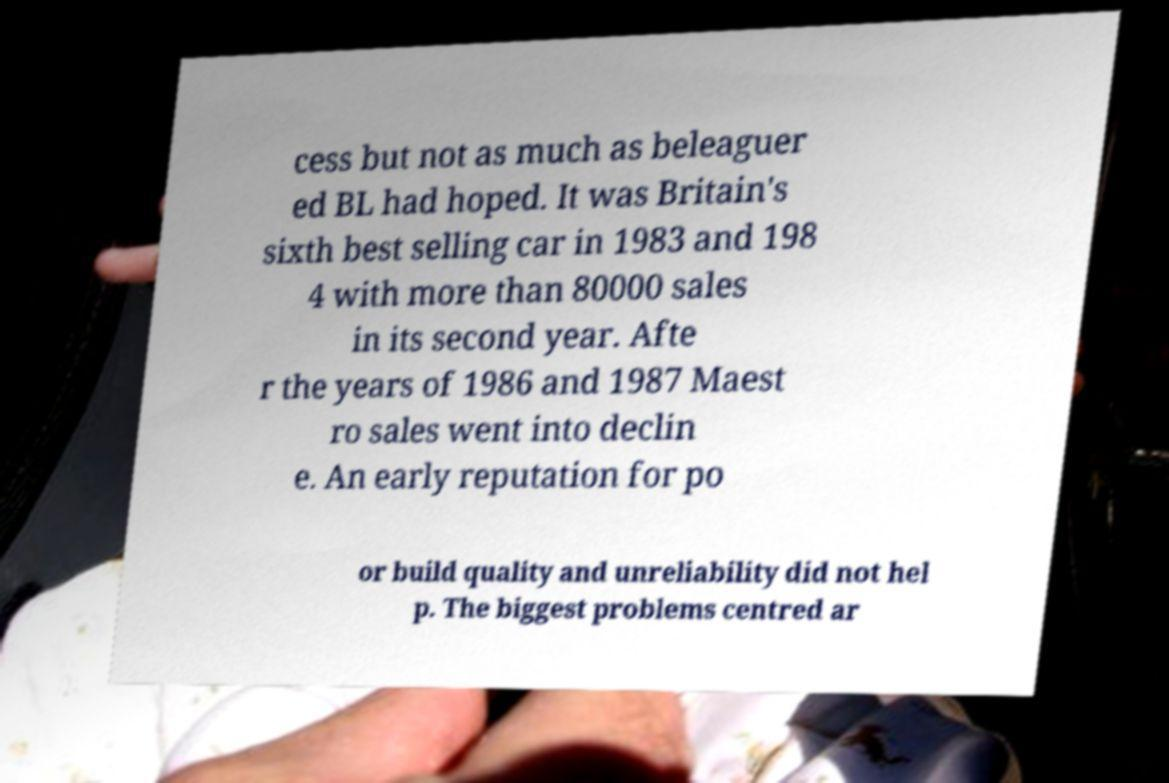There's text embedded in this image that I need extracted. Can you transcribe it verbatim? cess but not as much as beleaguer ed BL had hoped. It was Britain's sixth best selling car in 1983 and 198 4 with more than 80000 sales in its second year. Afte r the years of 1986 and 1987 Maest ro sales went into declin e. An early reputation for po or build quality and unreliability did not hel p. The biggest problems centred ar 